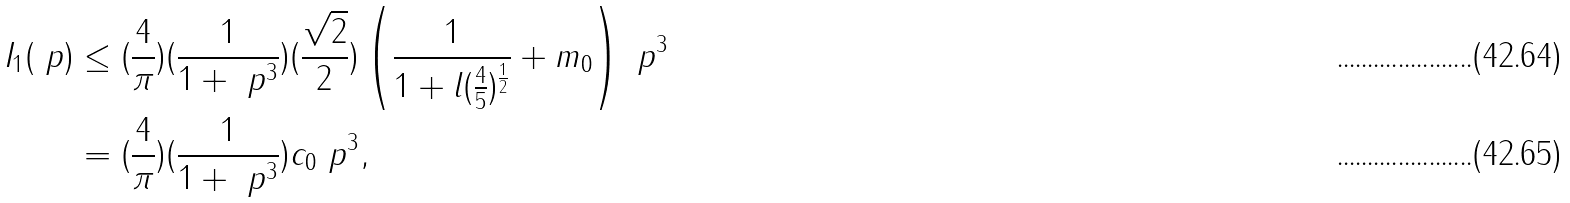Convert formula to latex. <formula><loc_0><loc_0><loc_500><loc_500>I _ { 1 } ( \ p ) & \leq ( \frac { 4 } { \pi } ) ( \frac { 1 } { 1 + \ p ^ { 3 } } ) ( \frac { \sqrt { 2 } } { 2 } ) \left ( \frac { 1 } { 1 + l ( \frac { 4 } { 5 } ) ^ { \frac { 1 } { 2 } } } + m _ { 0 } \right ) \ p ^ { 3 } \\ & = ( \frac { 4 } { \pi } ) ( \frac { 1 } { 1 + \ p ^ { 3 } } ) c _ { 0 } \ p ^ { 3 } ,</formula> 